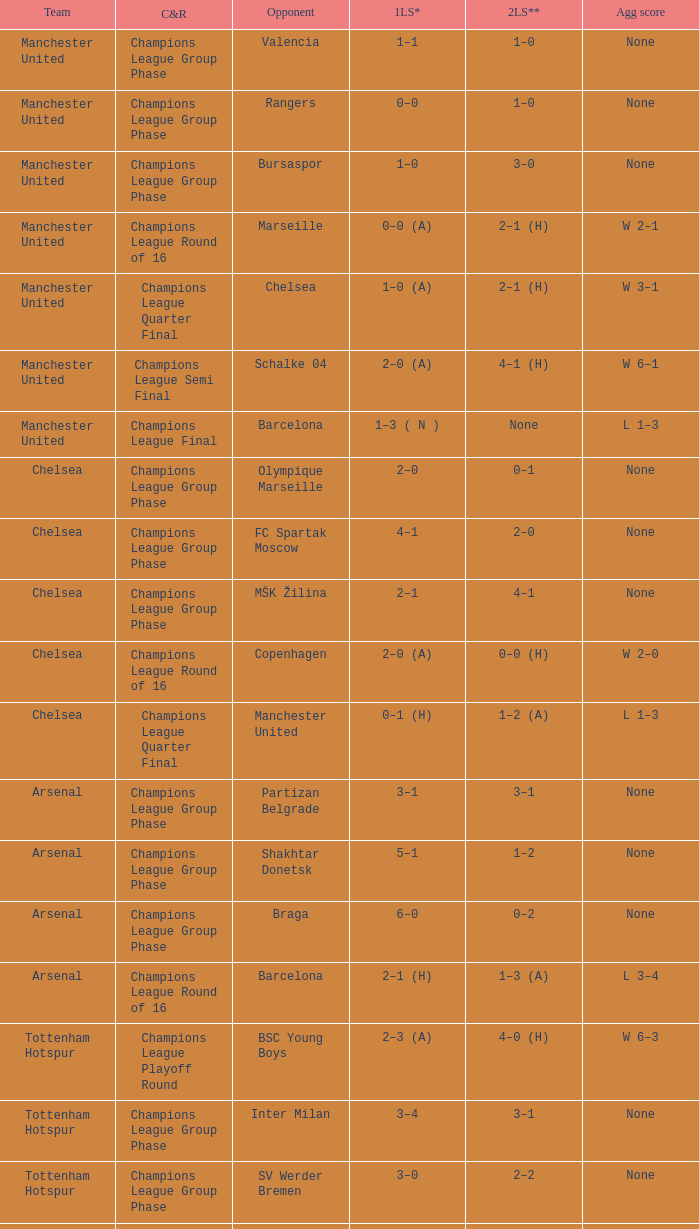How many goals did each team score in the first leg of the match between Liverpool and Steaua Bucureşti? 4–1. 